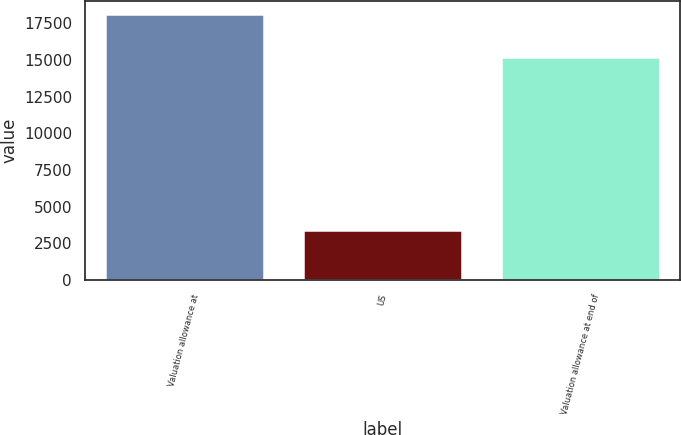Convert chart to OTSL. <chart><loc_0><loc_0><loc_500><loc_500><bar_chart><fcel>Valuation allowance at<fcel>US<fcel>Valuation allowance at end of<nl><fcel>18136<fcel>3419<fcel>15218<nl></chart> 